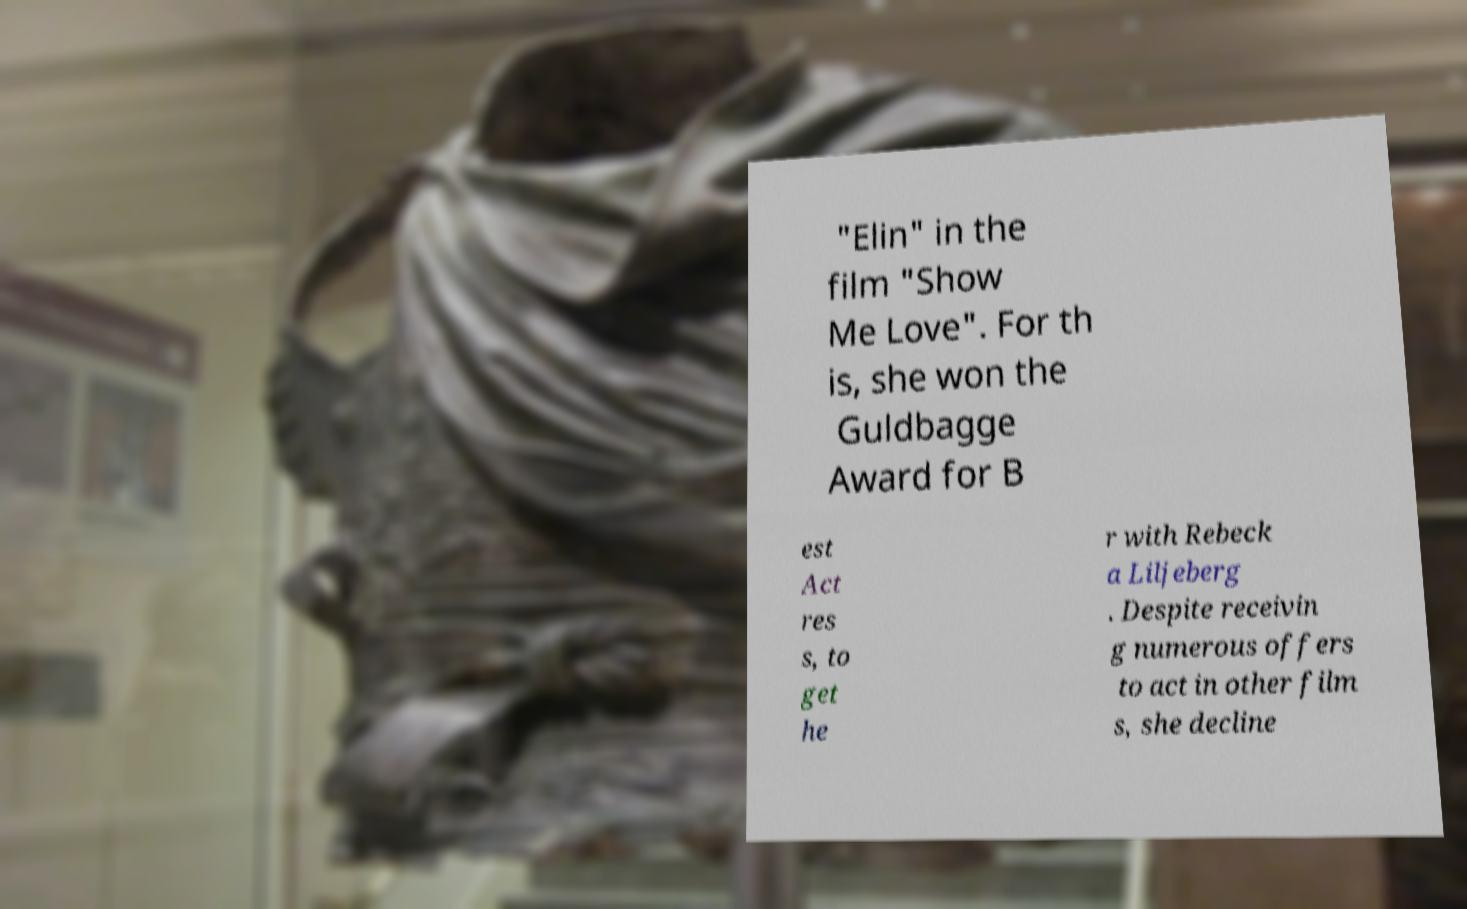Can you accurately transcribe the text from the provided image for me? "Elin" in the film "Show Me Love". For th is, she won the Guldbagge Award for B est Act res s, to get he r with Rebeck a Liljeberg . Despite receivin g numerous offers to act in other film s, she decline 